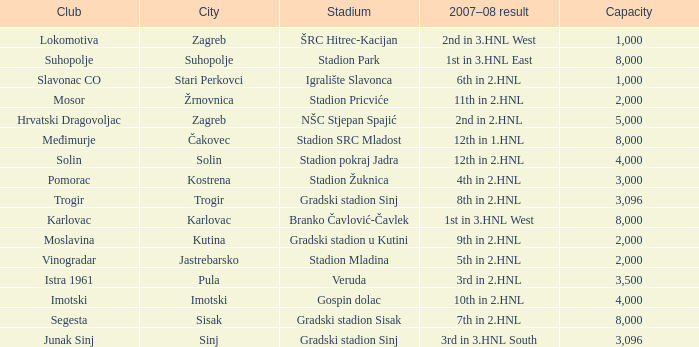What stadium has 9th in 2.hnl as the 2007-08 result? Gradski stadion u Kutini. 